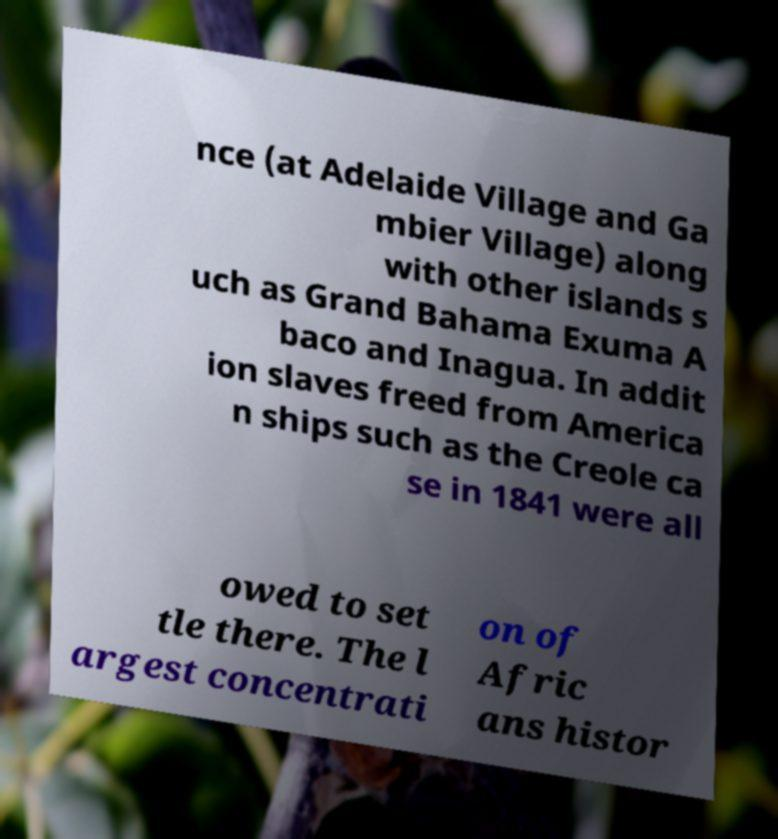There's text embedded in this image that I need extracted. Can you transcribe it verbatim? nce (at Adelaide Village and Ga mbier Village) along with other islands s uch as Grand Bahama Exuma A baco and Inagua. In addit ion slaves freed from America n ships such as the Creole ca se in 1841 were all owed to set tle there. The l argest concentrati on of Afric ans histor 